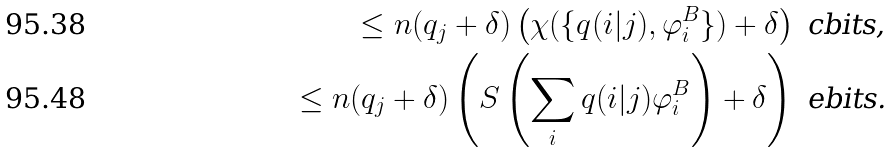<formula> <loc_0><loc_0><loc_500><loc_500>\leq n ( q _ { j } + \delta ) \left ( \chi ( \{ q ( i | j ) , \varphi ^ { B } _ { i } \} ) + \delta \right ) \text { cbits,} \\ \leq n ( q _ { j } + \delta ) \left ( S \left ( \sum _ { i } q ( i | j ) \varphi ^ { B } _ { i } \right ) + \delta \right ) \text { ebits.}</formula> 